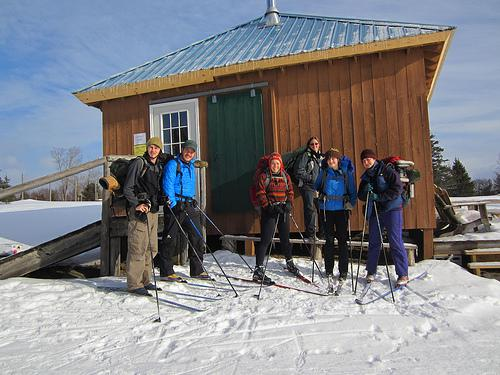Question: what color is the girl in the middle's hat?
Choices:
A. Green.
B. Orange.
C. Red.
D. Yellow.
Answer with the letter. Answer: C Question: why are they posing?
Choices:
A. For publicity.
B. They're friends.
C. Photo.
D. To remember the evening.
Answer with the letter. Answer: C Question: what are they wearing?
Choices:
A. Jackets.
B. Sweaters.
C. Snowsuits.
D. Sleeveless Dresses.
Answer with the letter. Answer: A Question: who is wearing sunglasses?
Choices:
A. The two kids.
B. A man.
C. The lady against the building.
D. The girl with the pink dress.
Answer with the letter. Answer: C Question: what color is the snow?
Choices:
A. Grey.
B. Yellow.
C. White.
D. Black.
Answer with the letter. Answer: C Question: what two colors are the signs beside the door?
Choices:
A. Red and blue.
B. Orange and green.
C. White and Yellow.
D. Purple and pink.
Answer with the letter. Answer: C Question: where is this scene?
Choices:
A. At a ski hill.
B. The mountain.
C. The country.
D. The city.
Answer with the letter. Answer: A 